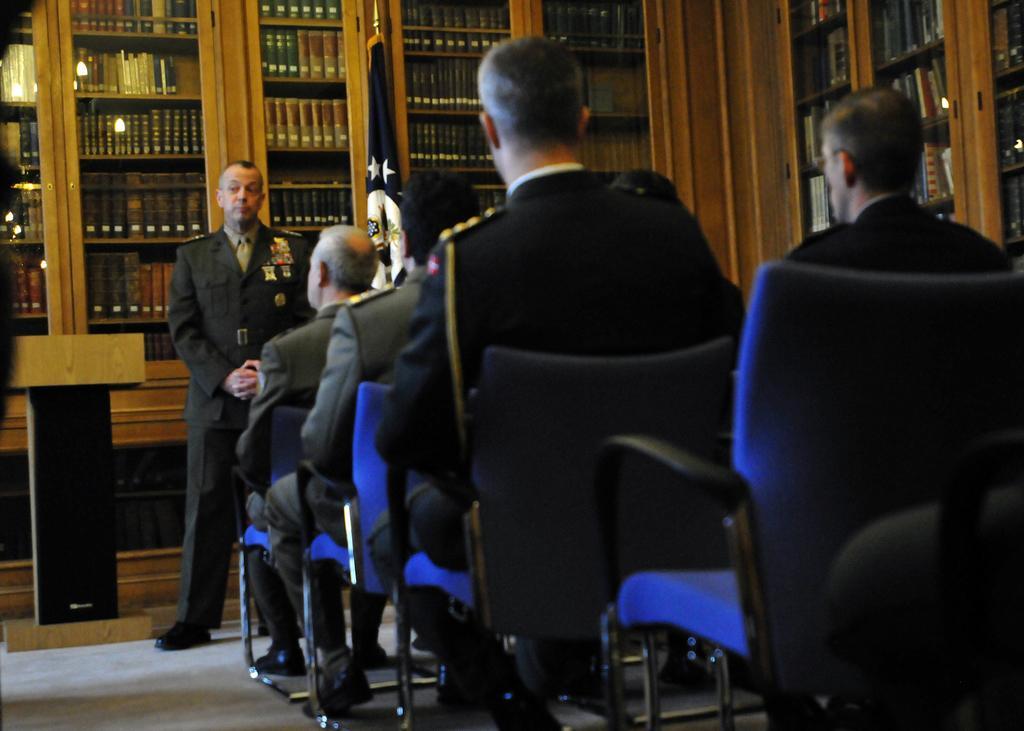Can you describe this image briefly? In this Image I see men who are sitting on chairs and there is a man over here who is standing and there is a podium over here. In the background I see racks which are full of books and there is a flag over here. 